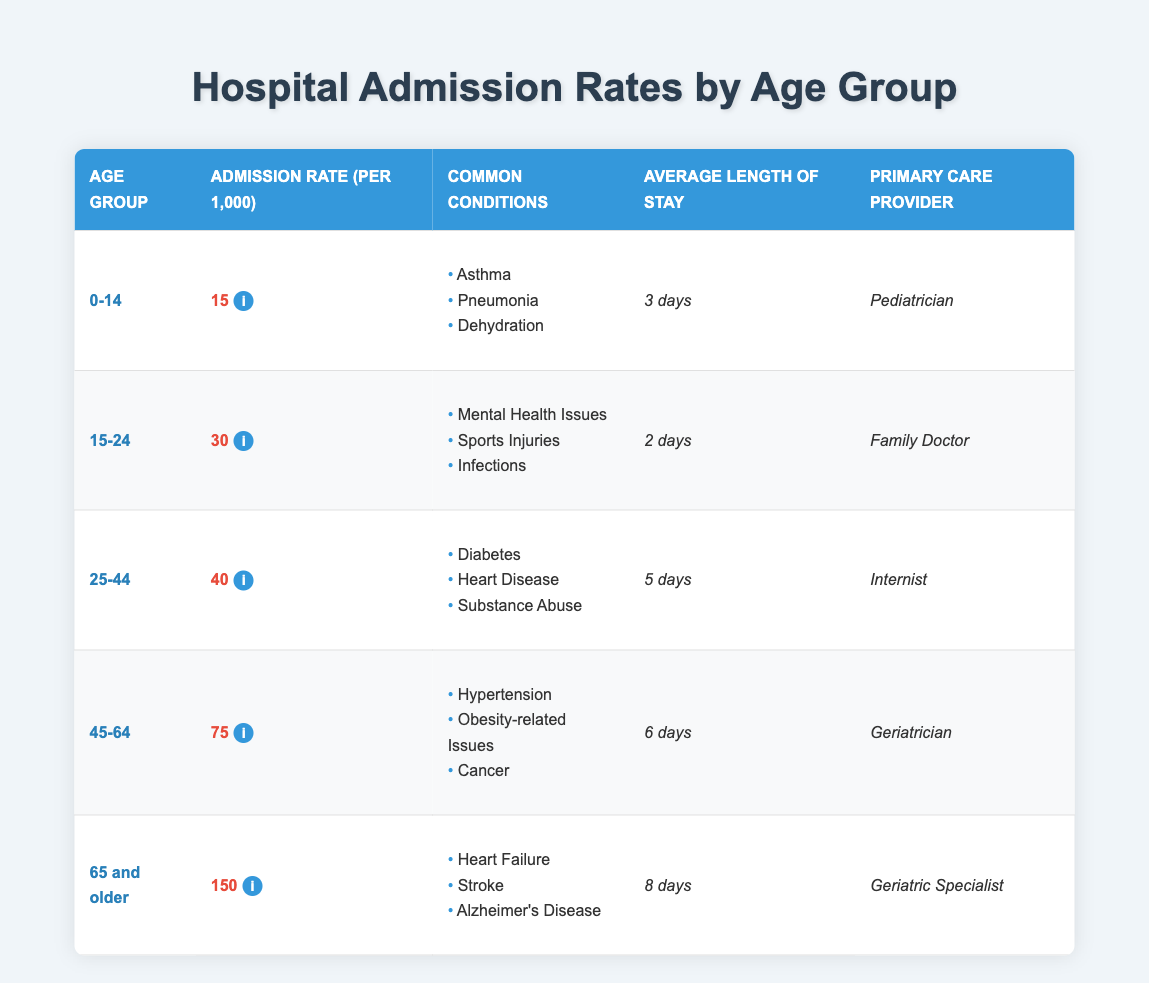What is the admission rate for the age group 45-64? The table displays the admission rates under the column for "Admission Rate (per 1,000)" alongside the respective age groups. For the age group 45-64, the admission rate is listed as 75.
Answer: 75 Which age group has the highest average length of stay? By comparing the values under the "Average Length of Stay" column, the age group 65 and older has the highest average length at 8 days.
Answer: 65 and older Are asthma and pneumonia common conditions in the age group 0-14? Looking at the "Common Conditions" column for the 0-14 age group, both asthma and pneumonia are listed. Therefore, the statement is true.
Answer: Yes What is the total admission rate for the age groups 25-44 and 45-64 combined? First, we find the individual admission rates: 25-44 has an admission rate of 40, and 45-64 has an admission rate of 75. Adding these together gives us 40 + 75 = 115.
Answer: 115 Is the primary care provider for the age group 65 and older a geriatrician? The table specifies that the primary care provider for the age group 65 and older is a "Geriatric Specialist," thus making the statement false.
Answer: No What is the average length of stay for patients in the age group 15-24 compared to those in the age group 25-44? The average length of stay for 15-24 is 2 days, and for 25-44, it is 5 days. To find the average of these two, we add 2 and 5 to get 7, and then divide by 2, resulting in an average of 3.5 days.
Answer: 3.5 Which age group has a significantly higher admission rate compared to the age group 0-14? The admission rate for 0-14 is 15, while 45-64 has an admission rate of 75. The difference is 75 - 15 = 60, indicating a significantly higher rate for 45-64.
Answer: 45-64 In which age group are mental health issues most commonly treated? According to the "Common Conditions" listed, mental health issues appear under the age group 15-24, so it is the age group where these issues are most commonly treated.
Answer: 15-24 What is the difference in admission rates between the age groups 0-14 and 25-44? The admission rate for 0-14 is 15, and for 25-44 it is 40. The difference is calculated as 40 - 15 = 25.
Answer: 25 